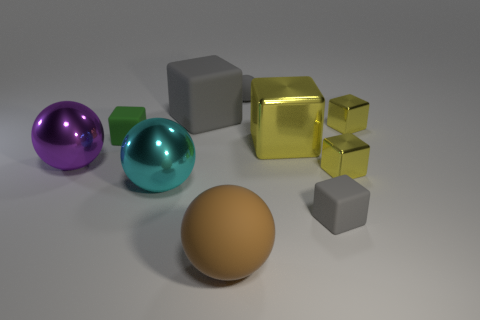How many yellow blocks must be subtracted to get 1 yellow blocks? 2 Subtract all big cyan balls. How many balls are left? 3 Subtract all purple cylinders. How many yellow cubes are left? 3 Subtract all gray blocks. How many blocks are left? 4 Subtract 0 red cylinders. How many objects are left? 10 Subtract all cubes. How many objects are left? 4 Subtract 3 balls. How many balls are left? 1 Subtract all green balls. Subtract all cyan blocks. How many balls are left? 4 Subtract all cyan objects. Subtract all big gray rubber objects. How many objects are left? 8 Add 5 yellow metallic cubes. How many yellow metallic cubes are left? 8 